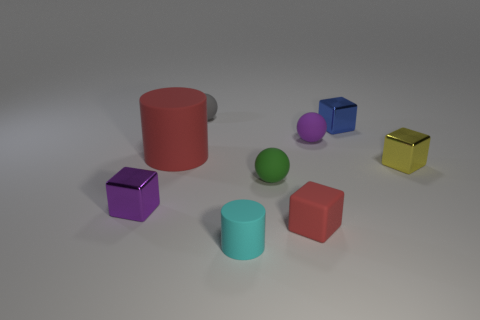How many other objects are the same material as the small yellow block?
Your answer should be very brief. 2. Do the gray rubber object and the cyan thing have the same size?
Offer a terse response. Yes. How many cubes are either big brown objects or large red rubber objects?
Ensure brevity in your answer.  0. What number of tiny rubber spheres are to the left of the matte cube and right of the tiny cyan object?
Your answer should be very brief. 1. There is a purple cube; is it the same size as the sphere to the left of the small cylinder?
Keep it short and to the point. Yes. There is a block that is to the left of the matte thing that is behind the purple matte thing; are there any spheres in front of it?
Your answer should be very brief. No. There is a cylinder that is to the left of the cylinder that is in front of the tiny purple metallic thing; what is its material?
Offer a very short reply. Rubber. What material is the small block that is both behind the purple metal thing and in front of the red matte cylinder?
Offer a very short reply. Metal. Are there any other tiny rubber things of the same shape as the gray rubber thing?
Provide a short and direct response. Yes. Is there a cylinder that is in front of the matte cylinder that is behind the purple shiny cube?
Provide a succinct answer. Yes. 